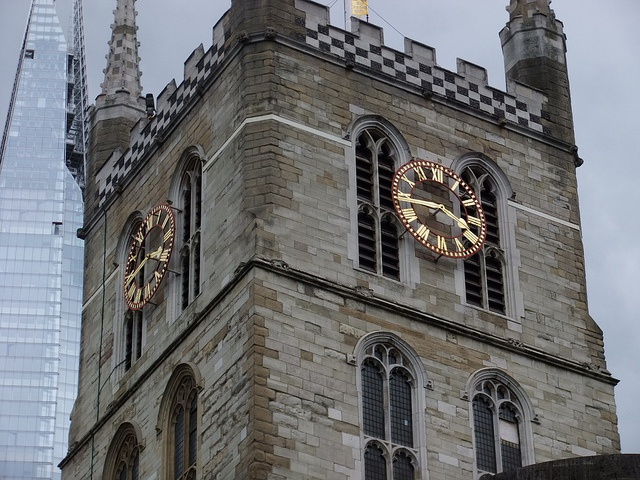Describe the objects in this image and their specific colors. I can see clock in darkgray, gray, black, maroon, and beige tones and clock in darkgray, black, gray, and tan tones in this image. 